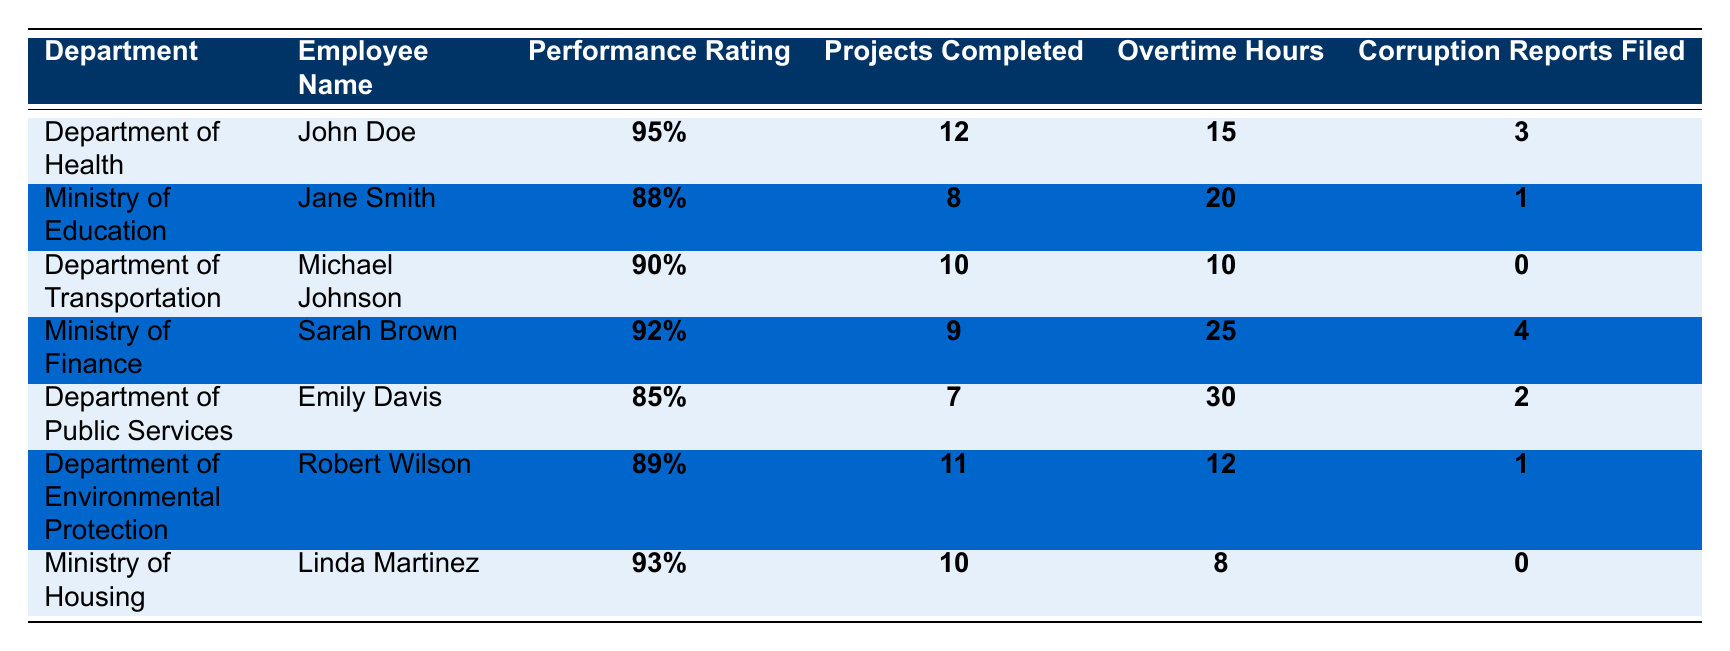What is the highest performance rating among employees? The highest performance rating listed is for John Doe in the Department of Health, which is 95%.
Answer: 95% How many projects did Sarah Brown complete? Sarah Brown from the Ministry of Finance completed 9 projects.
Answer: 9 Which department had the most corruption reports filed? The Department of Health, where John Doe filed 3 corruption reports, had the highest number of reports filed among all departments.
Answer: Department of Health What is the average number of projects completed by the employees? The total number of projects completed is (12 + 8 + 10 + 9 + 7 + 11 + 10) = 67. With 7 employees, the average is 67/7 = 9.57 (rounded).
Answer: 9.57 Did any employee file zero corruption reports? Yes, both Michael Johnson from the Department of Transportation and Linda Martinez from the Ministry of Housing filed zero corruption reports.
Answer: Yes What is the total number of overtime hours recorded for all employees? Adding the overtime hours: 15 + 20 + 10 + 25 + 30 + 12 + 8 = 120 total overtime hours.
Answer: 120 Which employee has the lowest performance rating? Emily Davis from the Department of Public Services has the lowest performance rating at 85%.
Answer: 85% How many employees completed more than 10 projects? Only John Doe from the Department of Health, who completed 12 projects, exceeded 10 projects.
Answer: 1 If we sum the corruption reports filed by all employees, what is the total? The sum of corruption reports filed is (3 + 1 + 0 + 4 + 2 + 1 + 0) = 11.
Answer: 11 Which department had the least overtime hours worked? The Ministry of Housing had the least overtime hours worked totaling 8 hours.
Answer: Ministry of Housing 